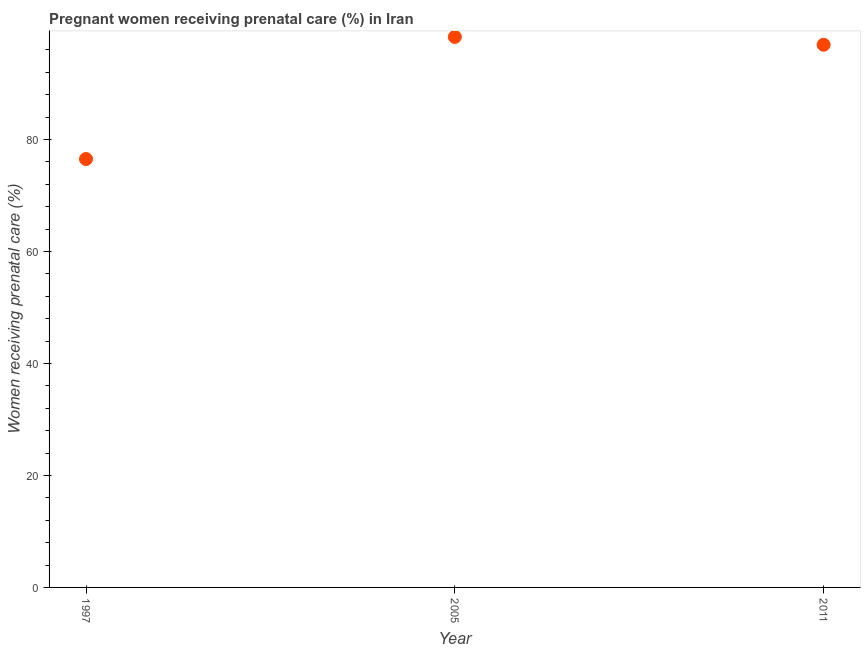What is the percentage of pregnant women receiving prenatal care in 1997?
Your answer should be compact. 76.5. Across all years, what is the maximum percentage of pregnant women receiving prenatal care?
Your answer should be very brief. 98.3. Across all years, what is the minimum percentage of pregnant women receiving prenatal care?
Offer a terse response. 76.5. What is the sum of the percentage of pregnant women receiving prenatal care?
Provide a short and direct response. 271.7. What is the difference between the percentage of pregnant women receiving prenatal care in 2005 and 2011?
Offer a terse response. 1.4. What is the average percentage of pregnant women receiving prenatal care per year?
Offer a terse response. 90.57. What is the median percentage of pregnant women receiving prenatal care?
Provide a succinct answer. 96.9. Do a majority of the years between 2011 and 2005 (inclusive) have percentage of pregnant women receiving prenatal care greater than 80 %?
Make the answer very short. No. What is the ratio of the percentage of pregnant women receiving prenatal care in 1997 to that in 2011?
Make the answer very short. 0.79. Is the percentage of pregnant women receiving prenatal care in 2005 less than that in 2011?
Provide a succinct answer. No. Is the difference between the percentage of pregnant women receiving prenatal care in 2005 and 2011 greater than the difference between any two years?
Your response must be concise. No. What is the difference between the highest and the second highest percentage of pregnant women receiving prenatal care?
Your answer should be very brief. 1.4. What is the difference between the highest and the lowest percentage of pregnant women receiving prenatal care?
Keep it short and to the point. 21.8. In how many years, is the percentage of pregnant women receiving prenatal care greater than the average percentage of pregnant women receiving prenatal care taken over all years?
Ensure brevity in your answer.  2. Does the percentage of pregnant women receiving prenatal care monotonically increase over the years?
Ensure brevity in your answer.  No. Does the graph contain any zero values?
Provide a short and direct response. No. What is the title of the graph?
Your response must be concise. Pregnant women receiving prenatal care (%) in Iran. What is the label or title of the Y-axis?
Provide a succinct answer. Women receiving prenatal care (%). What is the Women receiving prenatal care (%) in 1997?
Your answer should be compact. 76.5. What is the Women receiving prenatal care (%) in 2005?
Your response must be concise. 98.3. What is the Women receiving prenatal care (%) in 2011?
Provide a short and direct response. 96.9. What is the difference between the Women receiving prenatal care (%) in 1997 and 2005?
Make the answer very short. -21.8. What is the difference between the Women receiving prenatal care (%) in 1997 and 2011?
Offer a very short reply. -20.4. What is the ratio of the Women receiving prenatal care (%) in 1997 to that in 2005?
Give a very brief answer. 0.78. What is the ratio of the Women receiving prenatal care (%) in 1997 to that in 2011?
Your answer should be compact. 0.79. What is the ratio of the Women receiving prenatal care (%) in 2005 to that in 2011?
Offer a terse response. 1.01. 